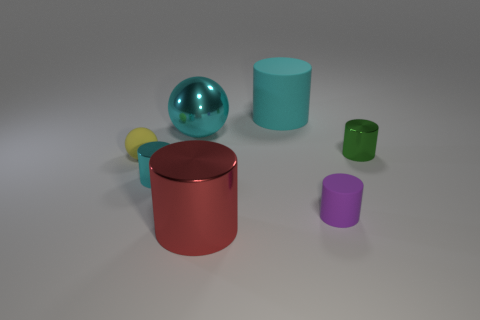The small yellow rubber thing is what shape?
Give a very brief answer. Sphere. What number of other things are the same shape as the big red thing?
Ensure brevity in your answer.  4. There is a large metallic thing that is behind the green shiny cylinder; what color is it?
Provide a succinct answer. Cyan. Are the cyan ball and the green cylinder made of the same material?
Offer a very short reply. Yes. How many things are rubber objects or large cylinders that are behind the red shiny cylinder?
Keep it short and to the point. 3. What is the size of the cylinder that is the same color as the large rubber object?
Ensure brevity in your answer.  Small. What is the shape of the small rubber object to the left of the small purple cylinder?
Provide a succinct answer. Sphere. Is the color of the large cylinder that is behind the large metal cylinder the same as the big metal sphere?
Give a very brief answer. Yes. There is a large object that is the same color as the big metal sphere; what material is it?
Provide a short and direct response. Rubber. Does the metallic cylinder that is on the left side of the cyan metal ball have the same size as the red cylinder?
Your answer should be very brief. No. 